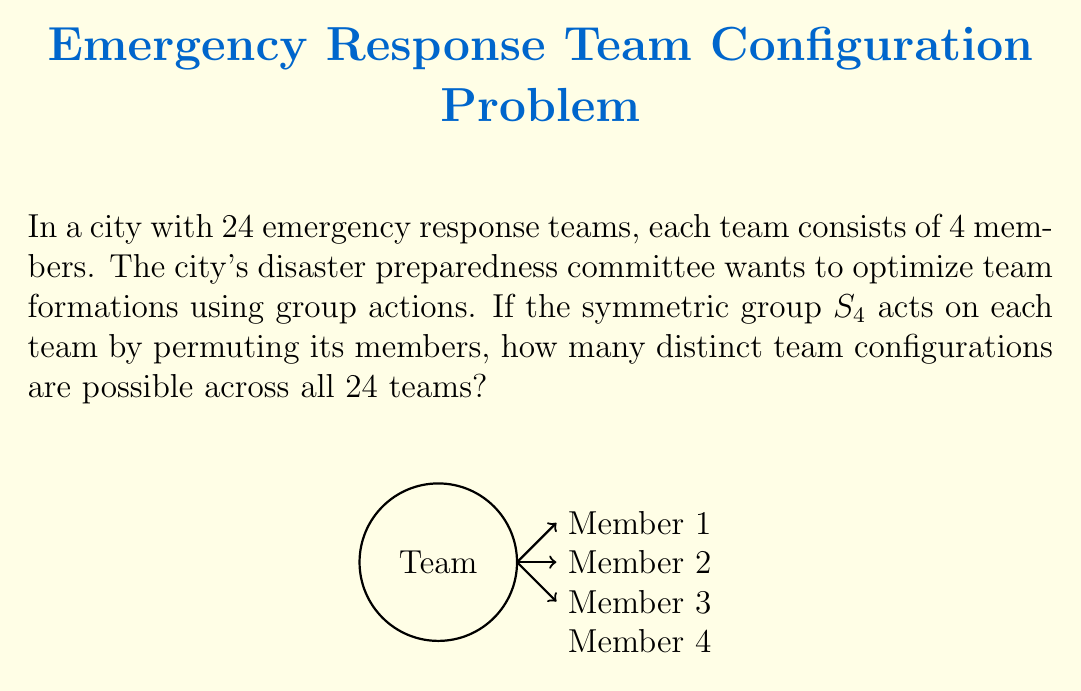Can you answer this question? Let's approach this step-by-step:

1) First, we need to understand what the question is asking. We have 24 teams, each with 4 members, and the symmetric group $S_4$ acts on each team.

2) The symmetric group $S_4$ consists of all permutations of 4 elements. The order of $S_4$ is $4! = 24$.

3) When $S_4$ acts on a team, it generates all possible arrangements of the 4 team members. However, some of these arrangements might be equivalent under the group action.

4) The number of distinct configurations for each team is equal to the number of orbits under this group action. We can calculate this using Burnside's lemma:

   $$|X/G| = \frac{1}{|G|} \sum_{g \in G} |X^g|$$

   Where $X$ is the set of all possible team arrangements, $G$ is our group $S_4$, and $X^g$ is the set of elements fixed by $g$.

5) In this case, $|G| = 24$, and we need to count the fixed points for each element of $S_4$:
   - The identity element fixes all 4! arrangements
   - 6 transpositions each fix 2! arrangements
   - 8 3-cycles each fix 1 arrangement
   - 6 double transpositions each fix 2! arrangements
   - 3 4-cycles each fix 0 arrangements

6) Applying Burnside's lemma:

   $$|X/G| = \frac{1}{24} (24 + 6 \cdot 2 + 8 \cdot 1 + 6 \cdot 2 + 3 \cdot 0) = \frac{1}{24} (24 + 12 + 8 + 12 + 0) = \frac{56}{24} = \frac{7}{3}$$

7) Therefore, each team has $\frac{7}{3}$ distinct configurations.

8) Since we have 24 teams, and each team's configuration is independent of the others, we multiply this by 24:

   $$24 \cdot \frac{7}{3} = 56$$

Thus, there are 56 distinct team configurations possible across all 24 teams.
Answer: 56 